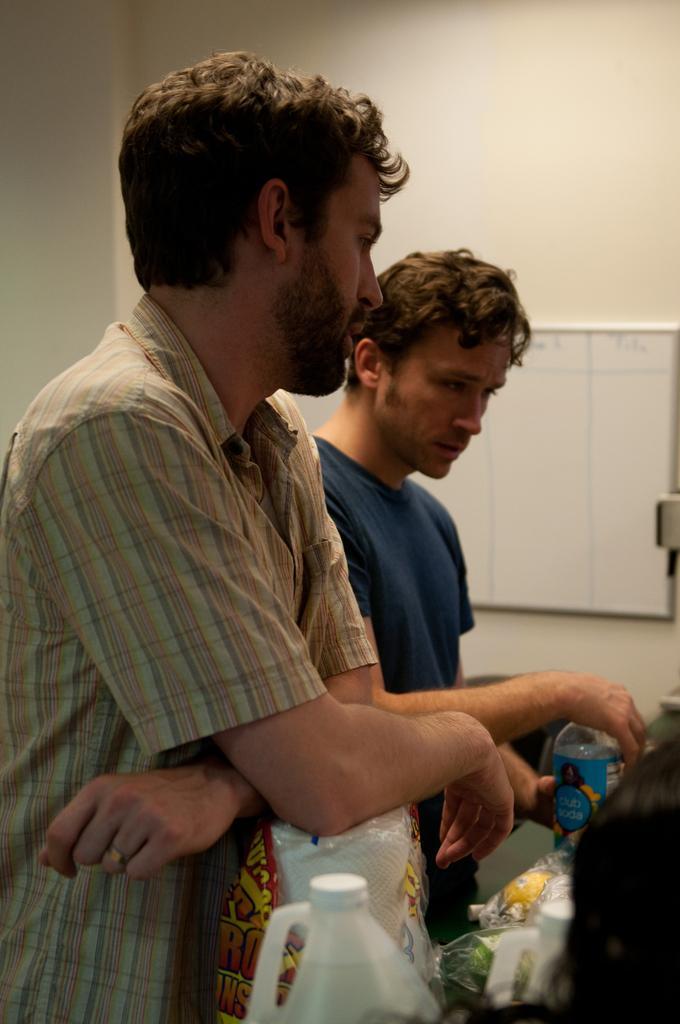Please provide a concise description of this image. There are two men standing, one person is wearing blocked shirt another person is wearing blue color shirt, both are looking at something,there is a bottle in the second person's hand and there are also few other utilities in front of them. In the background we can view a board and a white color wall. 